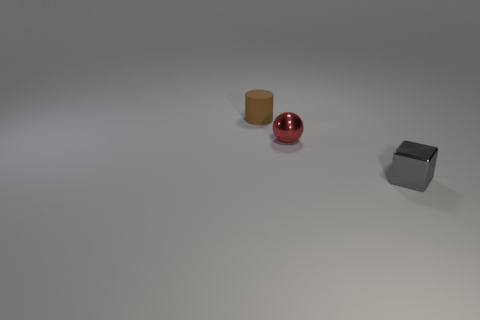Does the brown object have the same shape as the tiny red metal thing?
Your answer should be compact. No. What number of small brown matte cylinders are on the right side of the brown matte thing?
Your answer should be very brief. 0. What is the shape of the shiny object that is behind the metallic object that is right of the small red ball?
Provide a short and direct response. Sphere. There is a object that is the same material as the tiny red ball; what shape is it?
Give a very brief answer. Cube. Is the size of the metal object left of the tiny gray block the same as the metal object right of the small ball?
Give a very brief answer. Yes. What is the shape of the thing that is on the left side of the tiny ball?
Your answer should be compact. Cylinder. What color is the tiny ball?
Make the answer very short. Red. There is a gray metal block; does it have the same size as the object that is left of the shiny sphere?
Your answer should be compact. Yes. What number of shiny things are cubes or red objects?
Provide a short and direct response. 2. Are there any other things that have the same material as the tiny red sphere?
Ensure brevity in your answer.  Yes. 